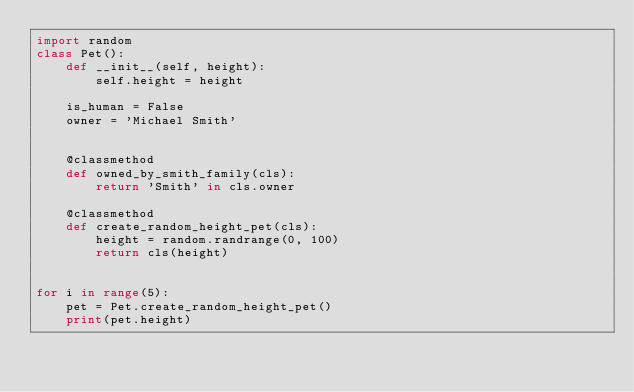<code> <loc_0><loc_0><loc_500><loc_500><_Python_>import random
class Pet():
    def __init__(self, height):
        self.height = height
    
    is_human = False
    owner = 'Michael Smith'


    @classmethod
    def owned_by_smith_family(cls):
        return 'Smith' in cls.owner

    @classmethod
    def create_random_height_pet(cls):
        height = random.randrange(0, 100)
        return cls(height)


for i in range(5):
    pet = Pet.create_random_height_pet()
    print(pet.height)</code> 